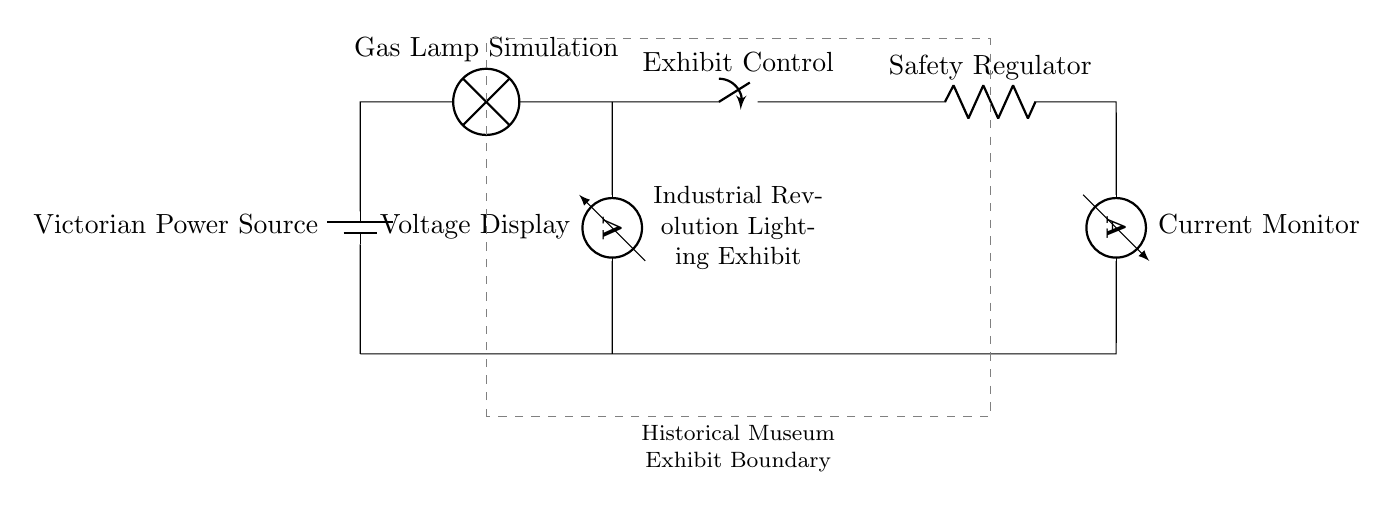What is the primary power source in this circuit? The primary power source is labeled as 'Victorian Power Source', representing the historic context of the exhibit.
Answer: Victorian Power Source What is the purpose of the switch in this circuit? The switch labeled 'Exhibit Control' serves as a device to turn the lighting system on or off for the exhibit, controlling visibility.
Answer: Exhibit Control How many lamps are present in the circuit? There is one lamp labeled 'Gas Lamp Simulation', indicating the type of lighting being used in the exhibit.
Answer: One What does the ammeter measure? The ammeter is labeled 'Current Monitor', which indicates its function to measure the amount of current flowing through the circuit.
Answer: Current Why is a resistor included in this series circuit? The resistor labeled 'Safety Regulator' is included to manage excessive current and protect the circuit components, ensuring safe operation.
Answer: Safety Regulator What is displayed by the voltmeter? The voltmeter is labeled 'Voltage Display' and provides a reading of the voltage across the lamp, crucial for understanding circuit performance.
Answer: Voltage Display 